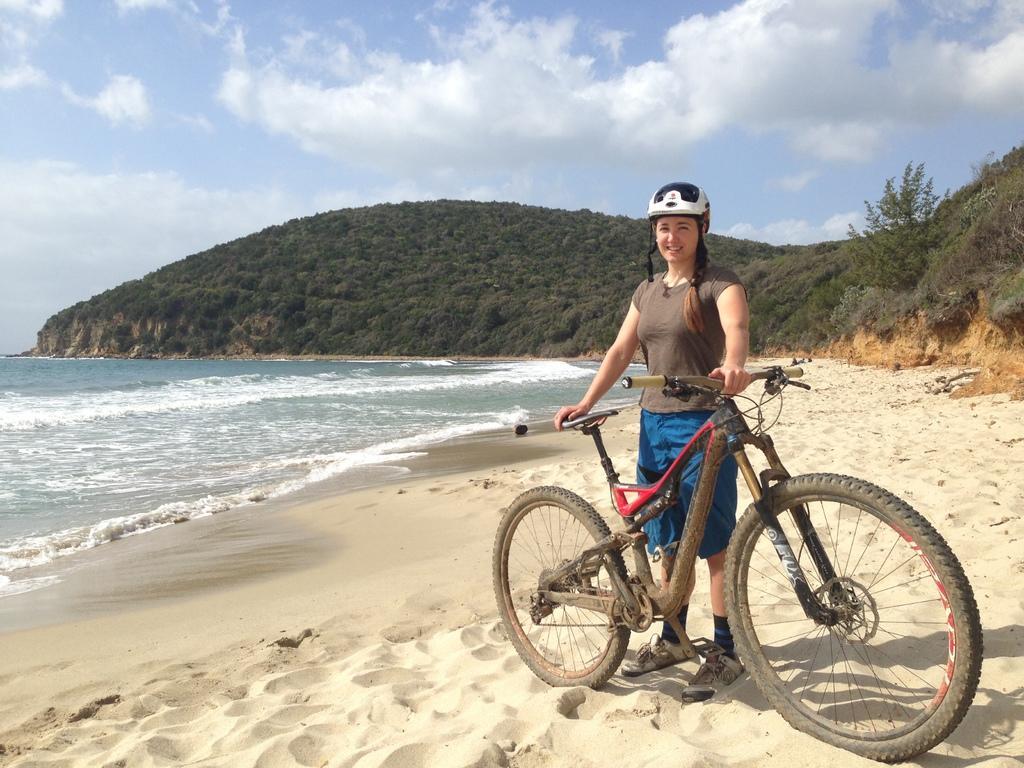Please provide a concise description of this image. In this image we can see a woman wearing brown color T-shirt, blue color short also wearing white color helmet holding bicycle which is on the ground and at the background of the image there are some mountains, water and sunny sky. 